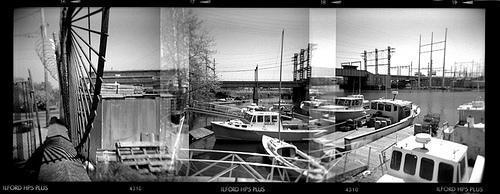How many windows are in the front of the closest boat?
Give a very brief answer. 4. 